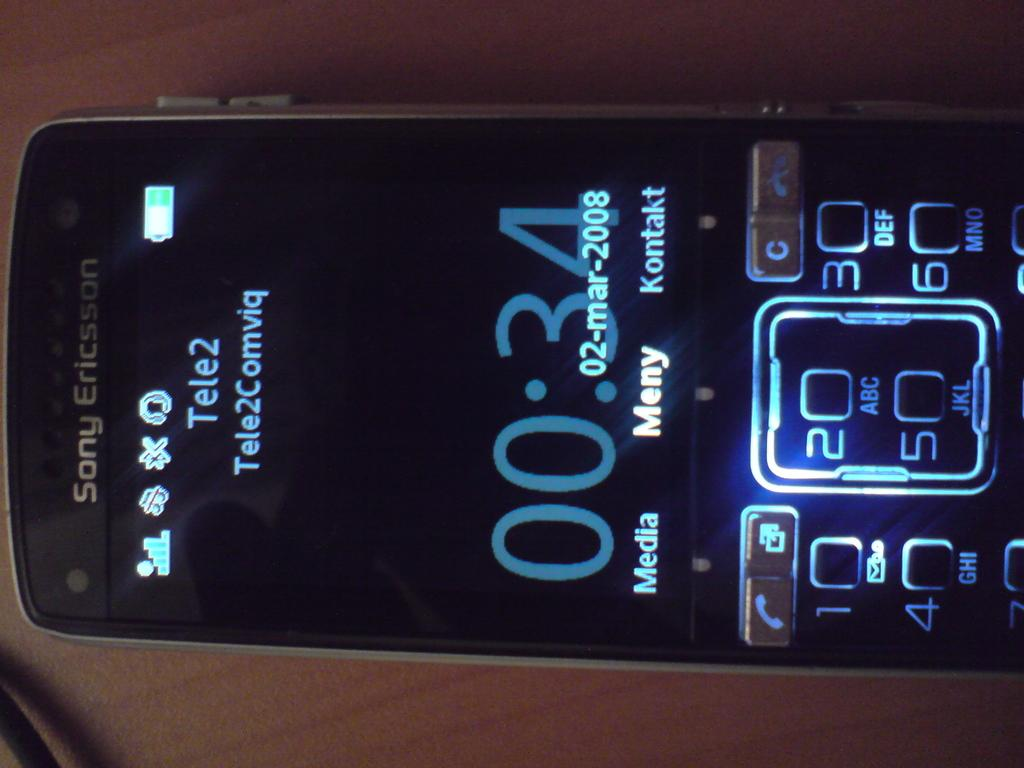<image>
Give a short and clear explanation of the subsequent image. A black Sony Ericsson phone shows the date as 02-mar-2008. 